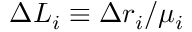Convert formula to latex. <formula><loc_0><loc_0><loc_500><loc_500>\Delta L _ { i } \equiv \Delta r _ { i } / \mu _ { i }</formula> 